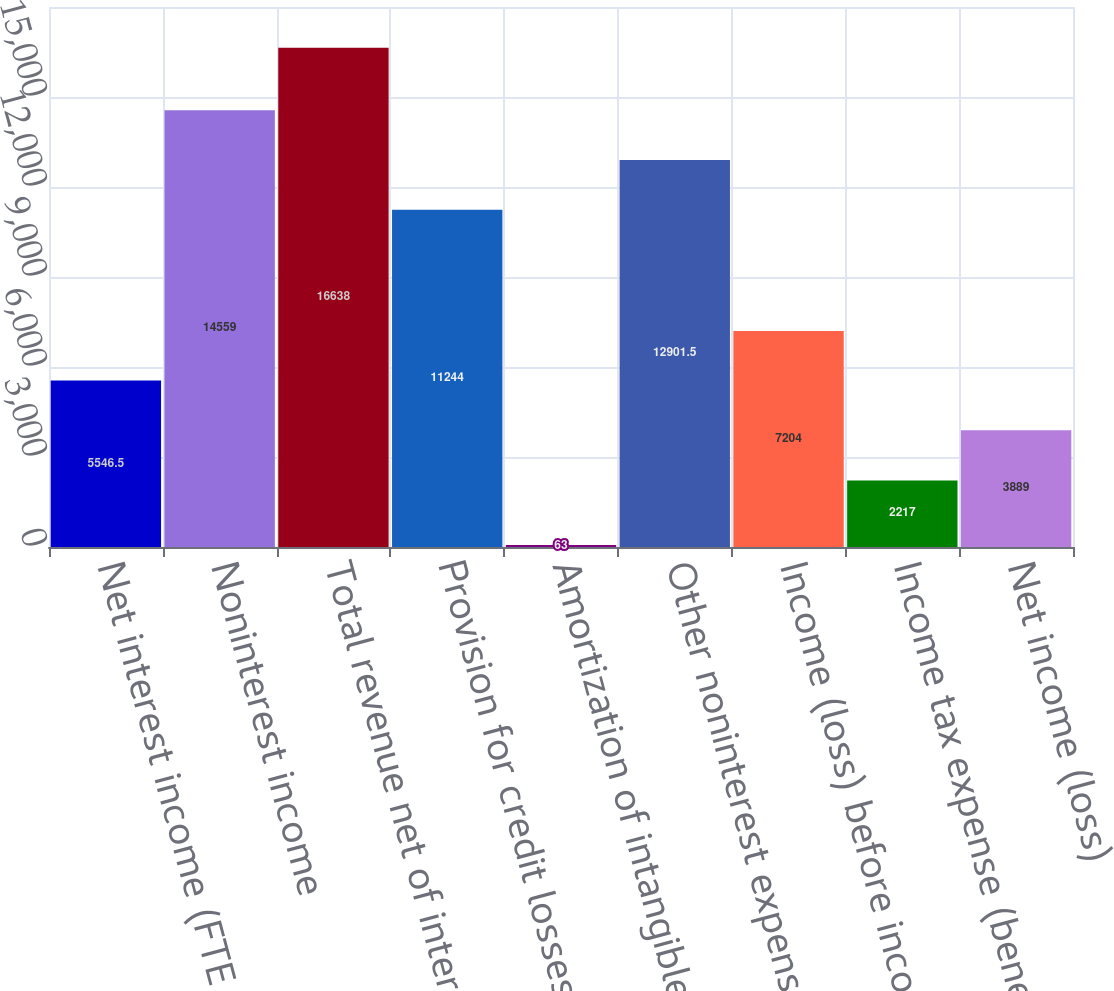<chart> <loc_0><loc_0><loc_500><loc_500><bar_chart><fcel>Net interest income (FTE<fcel>Noninterest income<fcel>Total revenue net of interest<fcel>Provision for credit losses<fcel>Amortization of intangibles<fcel>Other noninterest expense<fcel>Income (loss) before income<fcel>Income tax expense (benefit)<fcel>Net income (loss)<nl><fcel>5546.5<fcel>14559<fcel>16638<fcel>11244<fcel>63<fcel>12901.5<fcel>7204<fcel>2217<fcel>3889<nl></chart> 